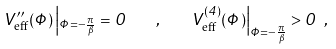<formula> <loc_0><loc_0><loc_500><loc_500>V ^ { \prime \prime } _ { \text {eff} } ( \Phi ) \left | _ { \Phi = - \frac { \pi } { \beta } } = 0 \quad , \quad V ^ { ( 4 ) } _ { \text {eff} } ( \Phi ) \right | _ { \Phi = - \frac { \pi } { \beta } } > 0 \ ,</formula> 